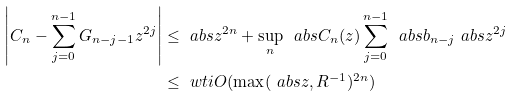<formula> <loc_0><loc_0><loc_500><loc_500>\left | C _ { n } - \sum _ { j = 0 } ^ { n - 1 } G _ { n - j - 1 } z ^ { 2 j } \right | & \leq \ a b s { z } ^ { 2 n } + \sup _ { n } \, \ a b s { C _ { n } ( z ) } \sum _ { j = 0 } ^ { n - 1 } \, \ a b s { b _ { n - j } } \ a b s { z ^ { 2 j } } \\ & \leq \ w t i O ( \max ( \ a b s { z } , R ^ { - 1 } ) ^ { 2 n } )</formula> 